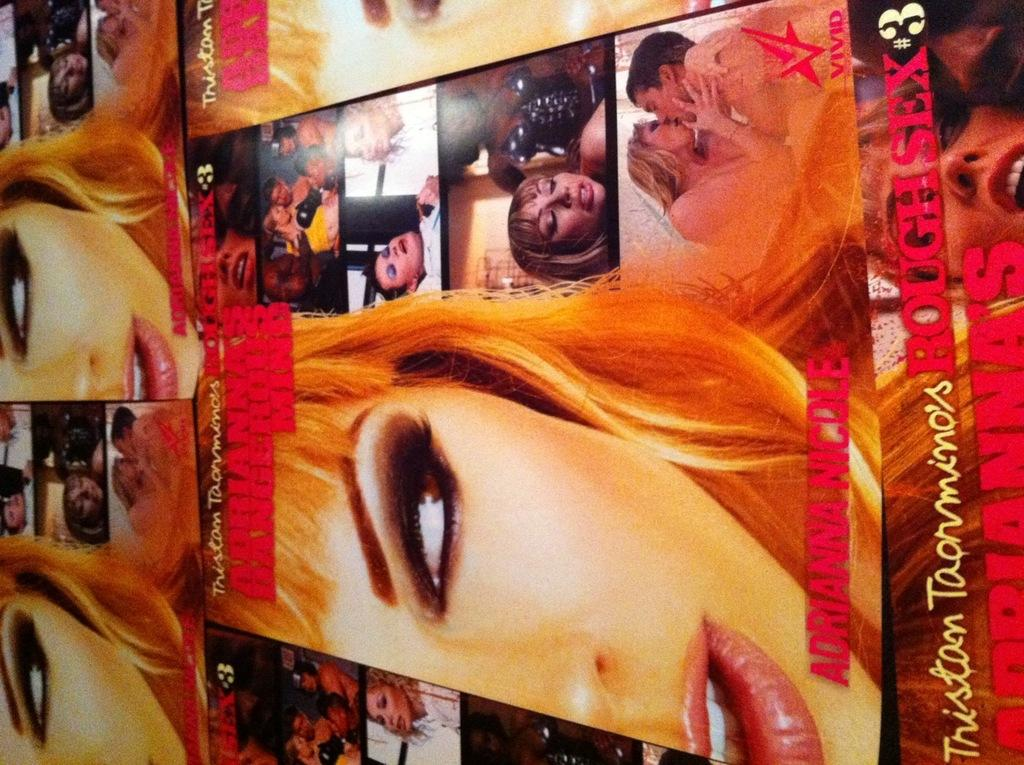Provide a one-sentence caption for the provided image. Picture showing a woman and man making out and the number 3 on the bottom. 